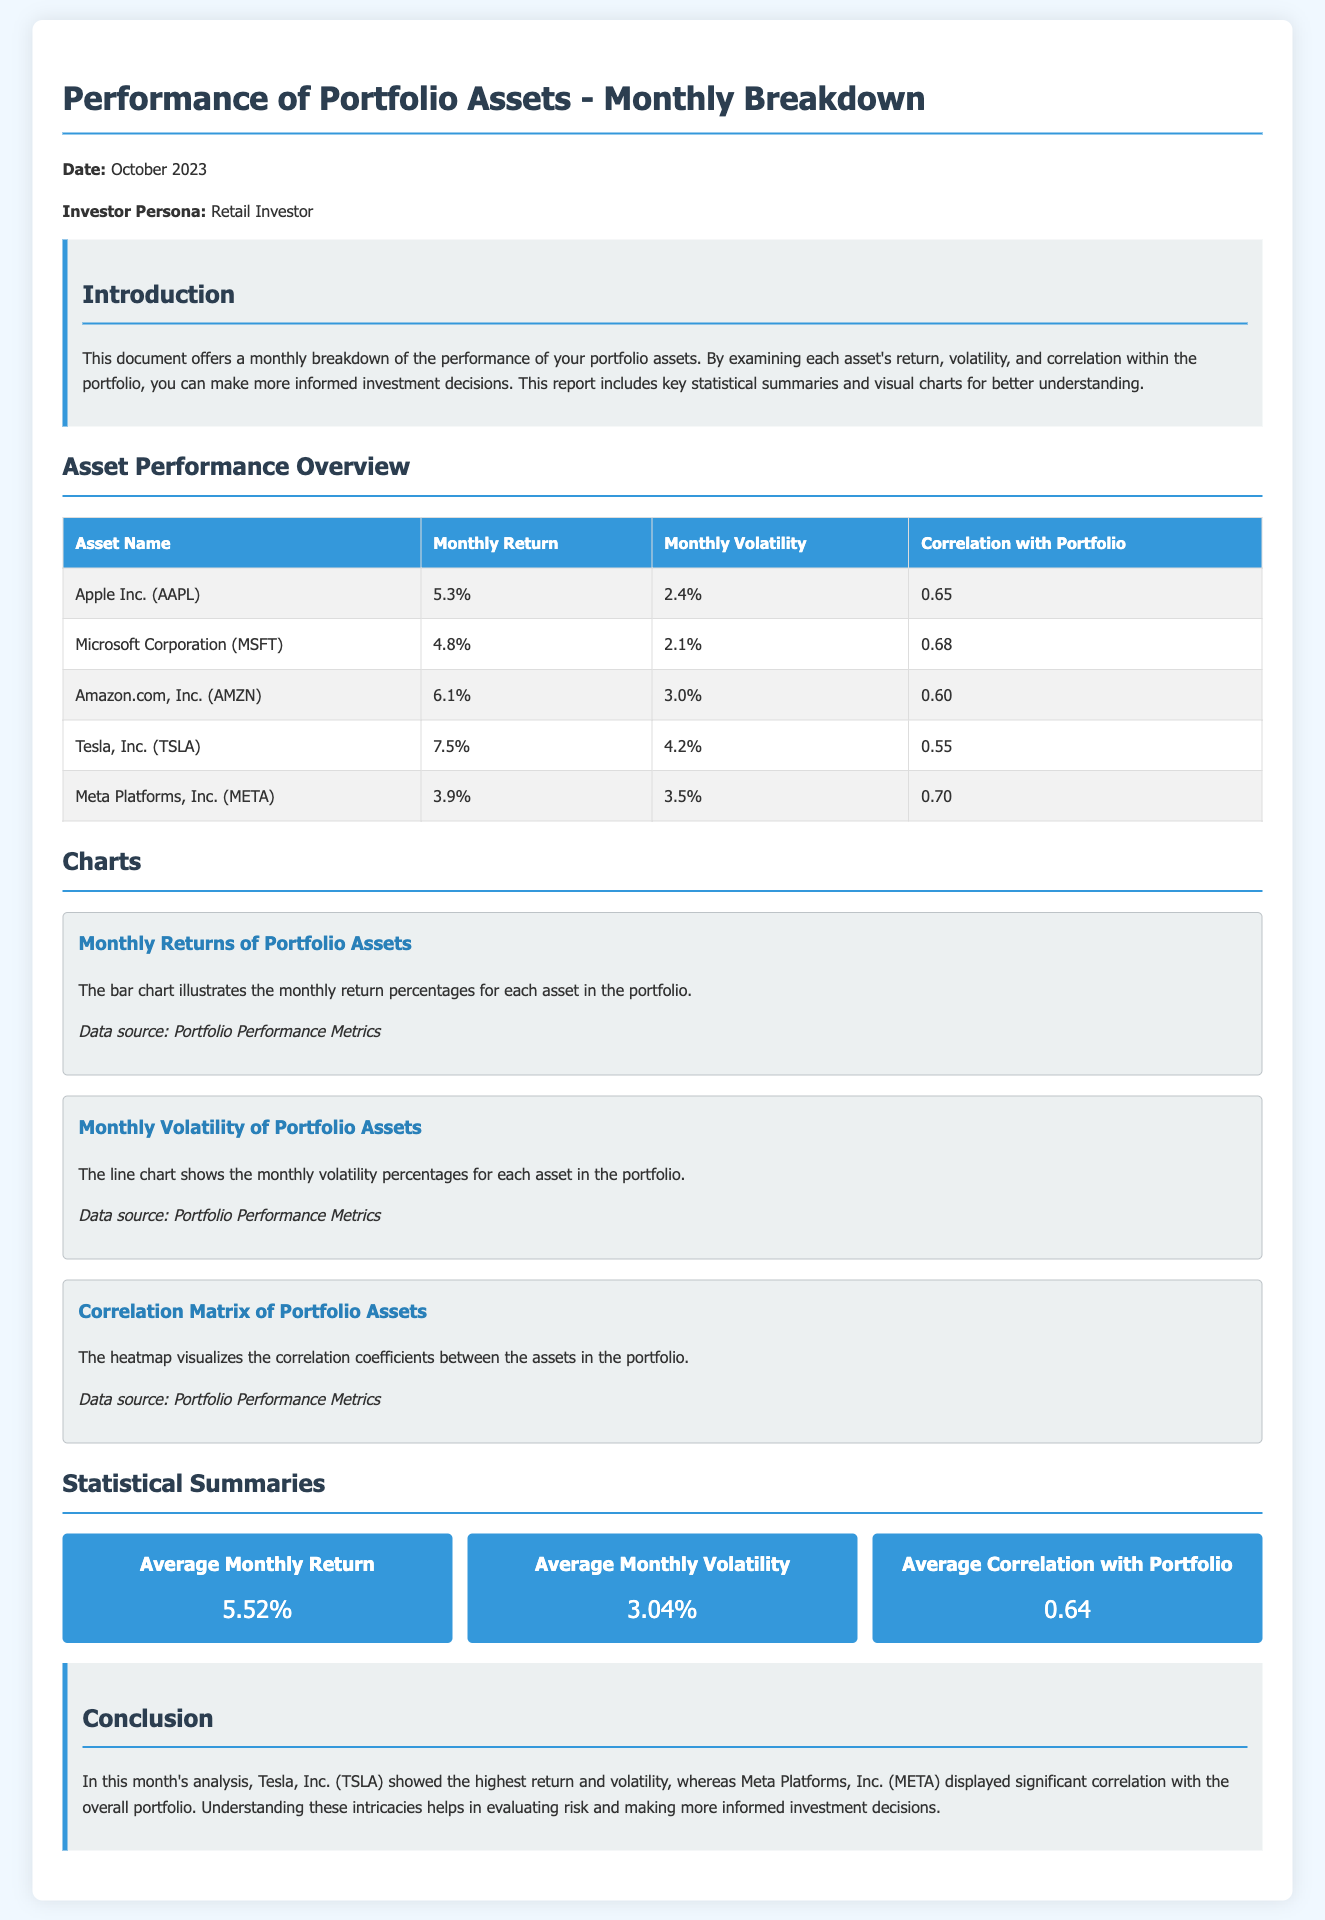What is the average monthly return? The average monthly return is calculated by averaging the monthly return percentages for all portfolio assets listed in the document.
Answer: 5.52% Which asset had the highest monthly volatility? The asset with the highest monthly volatility is identified by looking at the volatility values for each asset presented in the table.
Answer: Tesla, Inc. (TSLA) What is the correlation of Apple Inc. with the portfolio? The correlation of Apple Inc. with the portfolio is specifically noted in the correlation column for that asset.
Answer: 0.65 What percentage return did Meta Platforms, Inc. achieve? The return percentage for Meta Platforms, Inc. is directly provided in the return column of the asset performance overview table.
Answer: 3.9% What is the total number of assets listed in the performance overview? The total number of assets can be counted based on the rows presented in the performance overview table, excluding the header row.
Answer: 5 What correlation value indicates Tesla, Inc. with the portfolio? The correlation value for Tesla, Inc. is found in the correlation column of the table detailing each asset's performance.
Answer: 0.55 What does the first chart visualize? The first chart is described in the document, indicating what aspect of the data it presents.
Answer: Monthly Returns of Portfolio Assets Which asset showed the lowest return? The lowest return can be determined by comparing the monthly return percentages for each asset.
Answer: Meta Platforms, Inc. (META) What was the date of this report? The date is explicitly mentioned in the introductory section of the document.
Answer: October 2023 